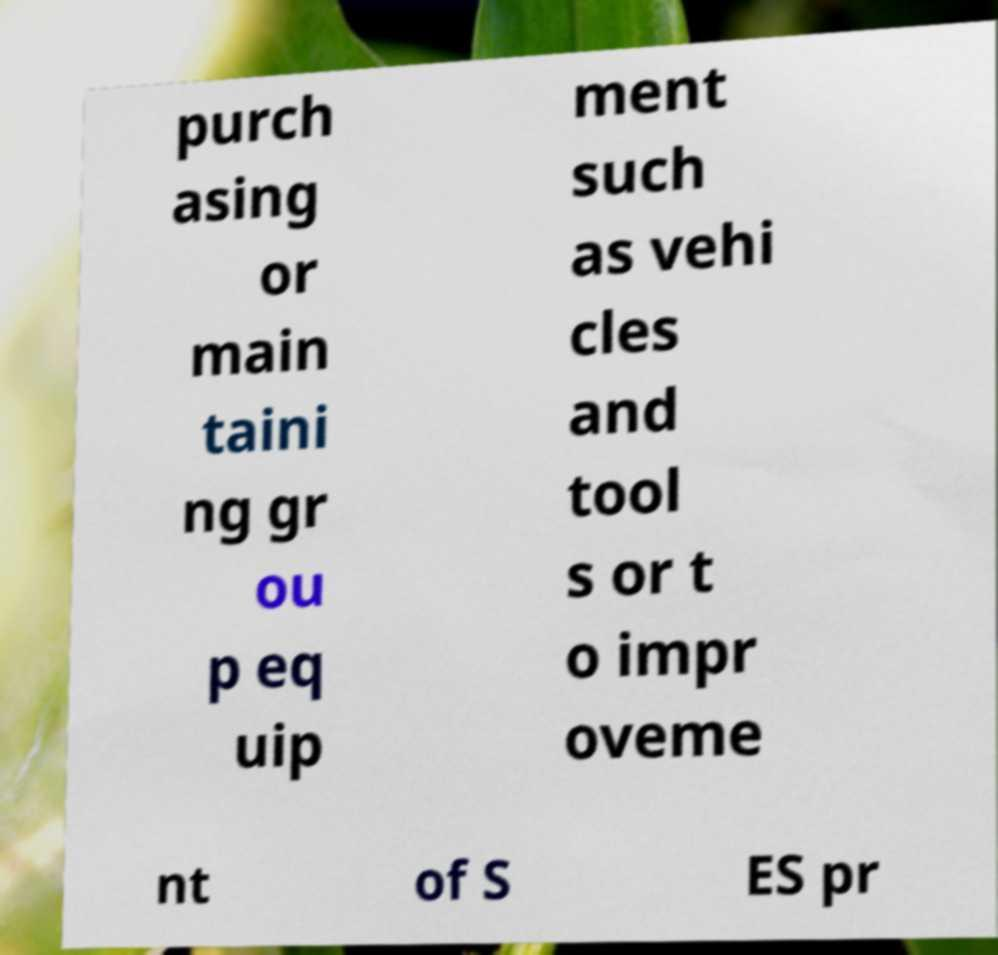There's text embedded in this image that I need extracted. Can you transcribe it verbatim? purch asing or main taini ng gr ou p eq uip ment such as vehi cles and tool s or t o impr oveme nt of S ES pr 